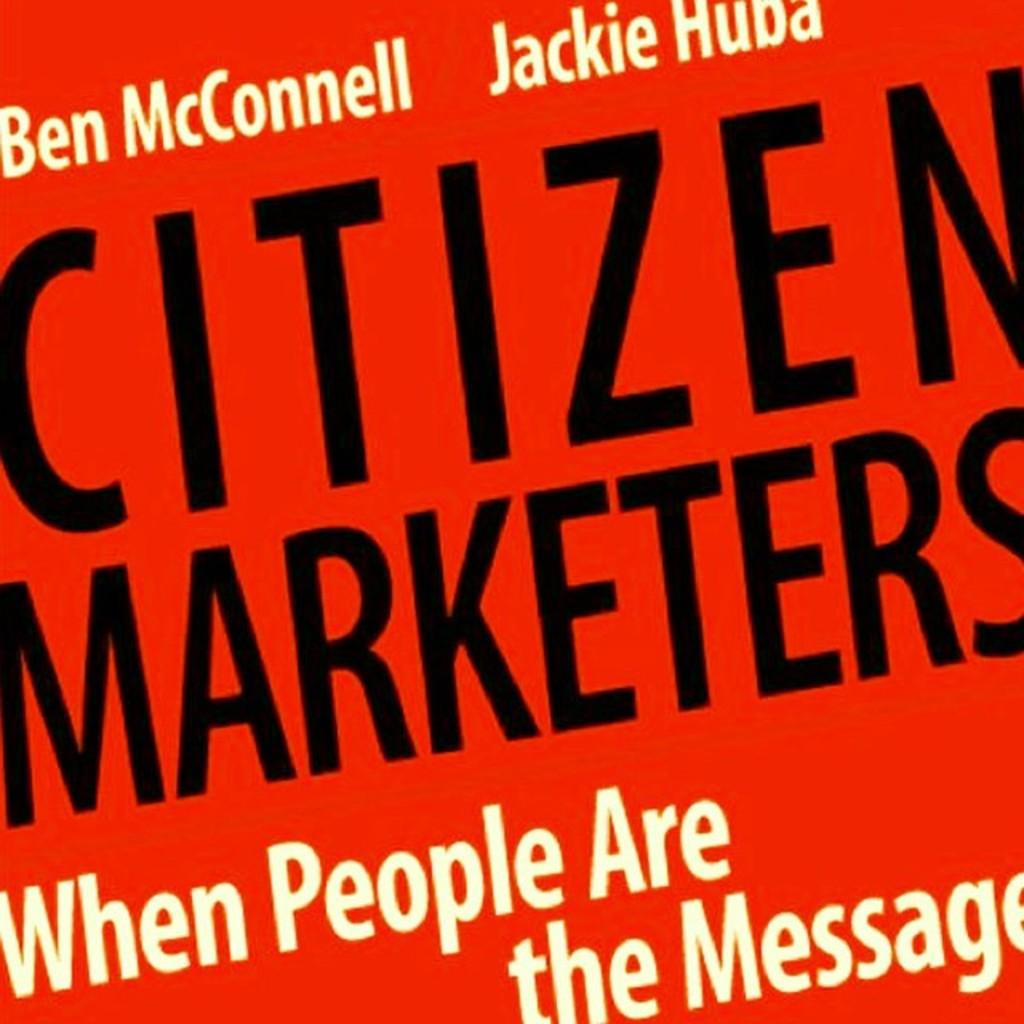<image>
Present a compact description of the photo's key features. A red sign titled Citizens Marketers, when people are the message. 